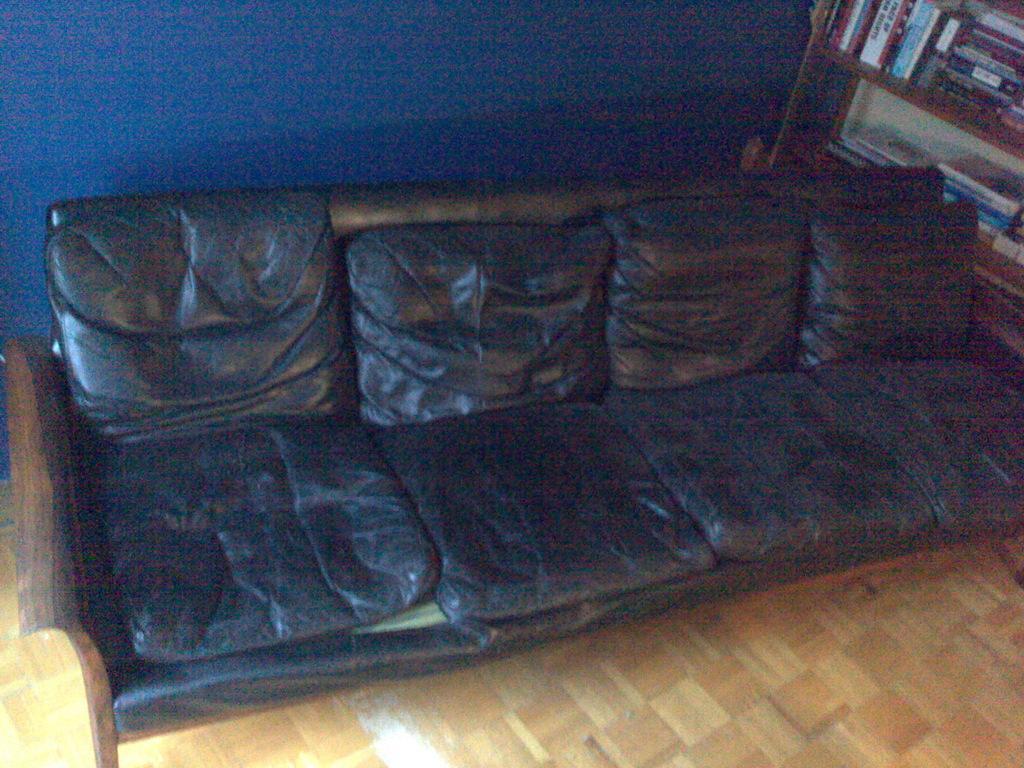How would you summarize this image in a sentence or two? This is a picture of a living room. In the center of the picture there is a black couch. On the top right there is a closet filled with books. On the top there is a blue wall. On the foreground floor is in wooden color. 